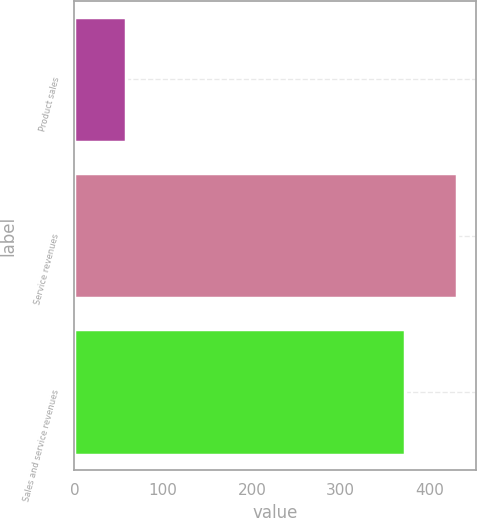Convert chart. <chart><loc_0><loc_0><loc_500><loc_500><bar_chart><fcel>Product sales<fcel>Service revenues<fcel>Sales and service revenues<nl><fcel>58<fcel>431<fcel>373<nl></chart> 